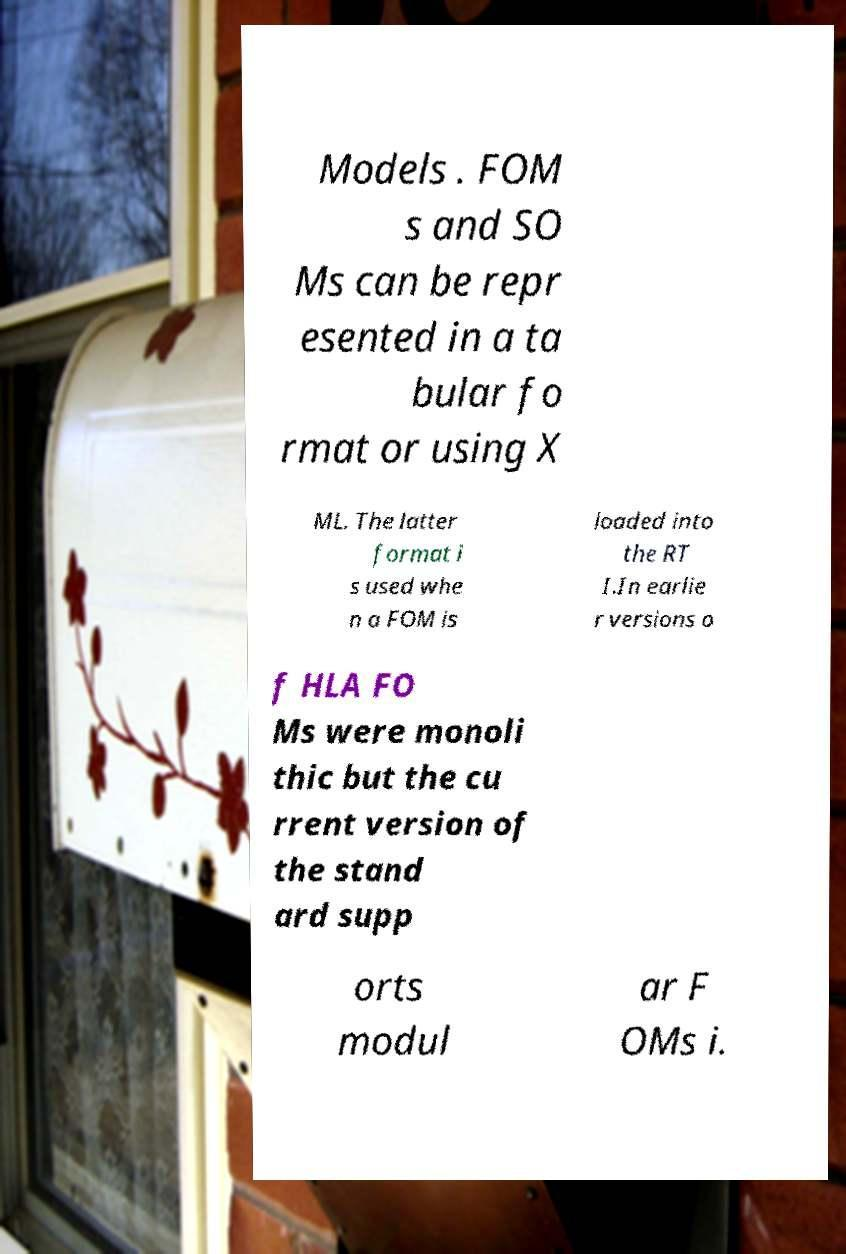Please read and relay the text visible in this image. What does it say? Models . FOM s and SO Ms can be repr esented in a ta bular fo rmat or using X ML. The latter format i s used whe n a FOM is loaded into the RT I.In earlie r versions o f HLA FO Ms were monoli thic but the cu rrent version of the stand ard supp orts modul ar F OMs i. 